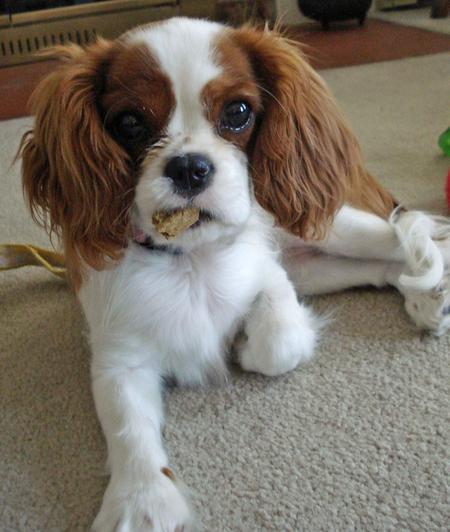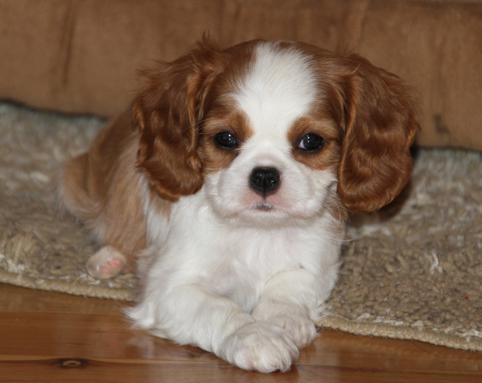The first image is the image on the left, the second image is the image on the right. Given the left and right images, does the statement "The dog in the image on the left is outside." hold true? Answer yes or no. No. 